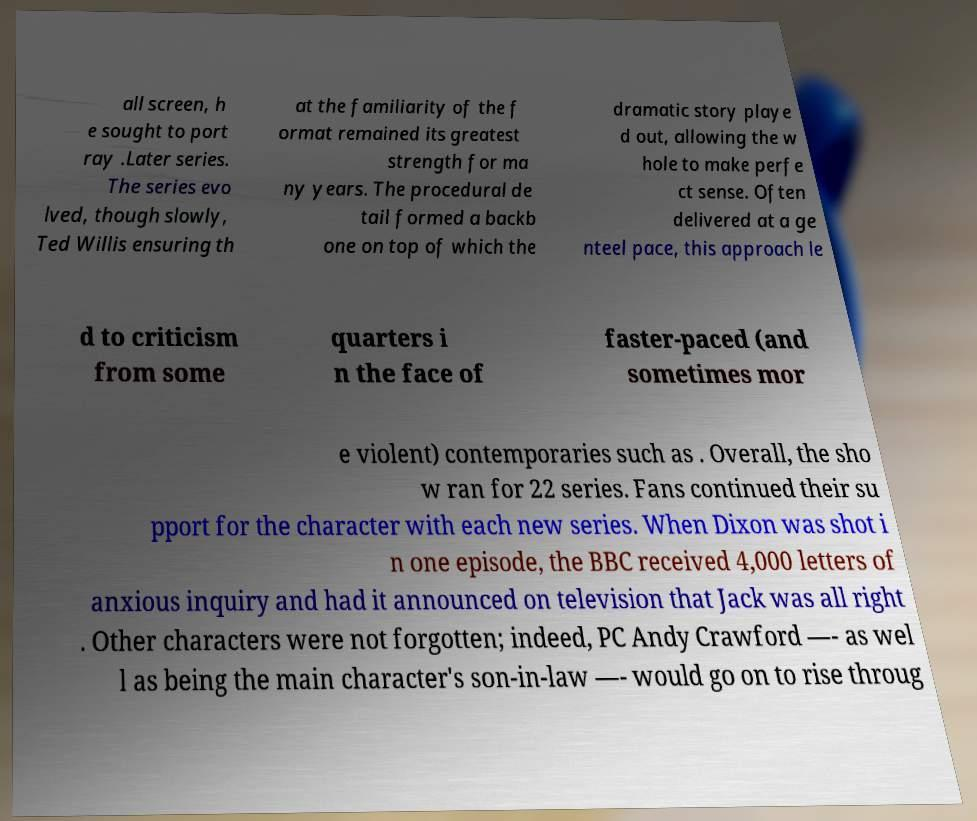I need the written content from this picture converted into text. Can you do that? all screen, h e sought to port ray .Later series. The series evo lved, though slowly, Ted Willis ensuring th at the familiarity of the f ormat remained its greatest strength for ma ny years. The procedural de tail formed a backb one on top of which the dramatic story playe d out, allowing the w hole to make perfe ct sense. Often delivered at a ge nteel pace, this approach le d to criticism from some quarters i n the face of faster-paced (and sometimes mor e violent) contemporaries such as . Overall, the sho w ran for 22 series. Fans continued their su pport for the character with each new series. When Dixon was shot i n one episode, the BBC received 4,000 letters of anxious inquiry and had it announced on television that Jack was all right . Other characters were not forgotten; indeed, PC Andy Crawford —- as wel l as being the main character's son-in-law —- would go on to rise throug 